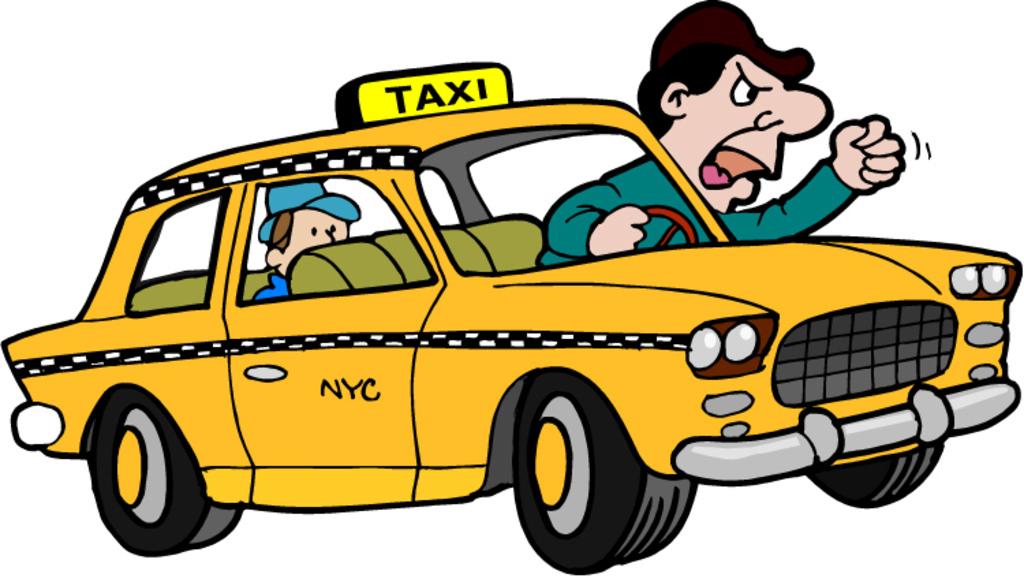Where is the cartoon taxi from?
Ensure brevity in your answer.  Nyc. What type of vehicle is this?
Provide a succinct answer. Taxi. 